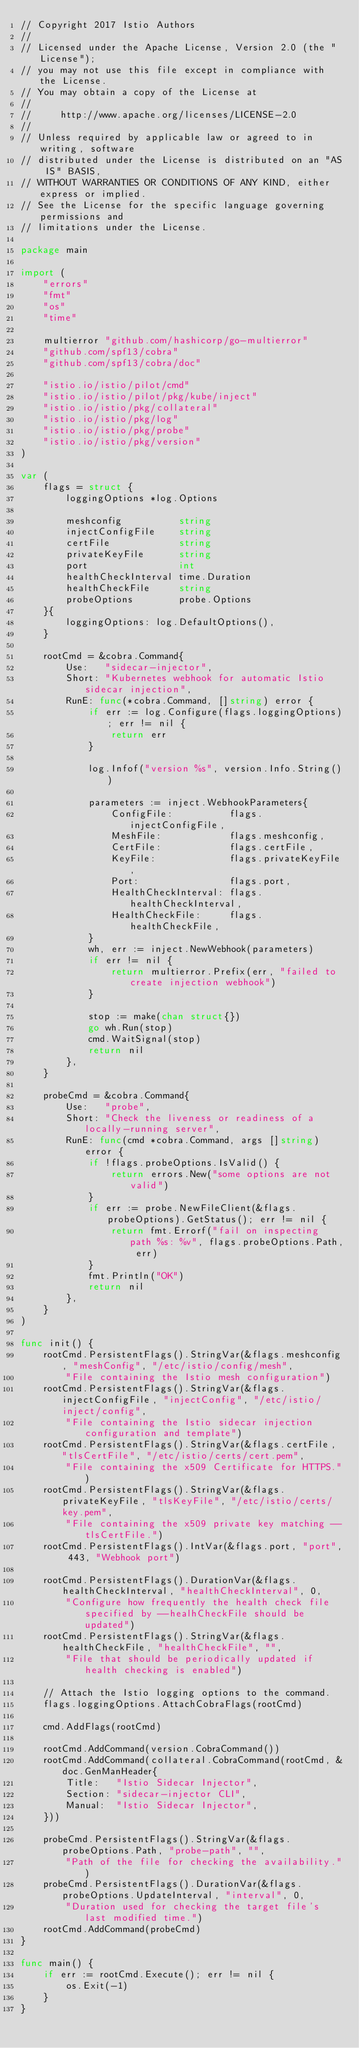<code> <loc_0><loc_0><loc_500><loc_500><_Go_>// Copyright 2017 Istio Authors
//
// Licensed under the Apache License, Version 2.0 (the "License");
// you may not use this file except in compliance with the License.
// You may obtain a copy of the License at
//
//     http://www.apache.org/licenses/LICENSE-2.0
//
// Unless required by applicable law or agreed to in writing, software
// distributed under the License is distributed on an "AS IS" BASIS,
// WITHOUT WARRANTIES OR CONDITIONS OF ANY KIND, either express or implied.
// See the License for the specific language governing permissions and
// limitations under the License.

package main

import (
	"errors"
	"fmt"
	"os"
	"time"

	multierror "github.com/hashicorp/go-multierror"
	"github.com/spf13/cobra"
	"github.com/spf13/cobra/doc"

	"istio.io/istio/pilot/cmd"
	"istio.io/istio/pilot/pkg/kube/inject"
	"istio.io/istio/pkg/collateral"
	"istio.io/istio/pkg/log"
	"istio.io/istio/pkg/probe"
	"istio.io/istio/pkg/version"
)

var (
	flags = struct {
		loggingOptions *log.Options

		meshconfig          string
		injectConfigFile    string
		certFile            string
		privateKeyFile      string
		port                int
		healthCheckInterval time.Duration
		healthCheckFile     string
		probeOptions        probe.Options
	}{
		loggingOptions: log.DefaultOptions(),
	}

	rootCmd = &cobra.Command{
		Use:   "sidecar-injector",
		Short: "Kubernetes webhook for automatic Istio sidecar injection",
		RunE: func(*cobra.Command, []string) error {
			if err := log.Configure(flags.loggingOptions); err != nil {
				return err
			}

			log.Infof("version %s", version.Info.String())

			parameters := inject.WebhookParameters{
				ConfigFile:          flags.injectConfigFile,
				MeshFile:            flags.meshconfig,
				CertFile:            flags.certFile,
				KeyFile:             flags.privateKeyFile,
				Port:                flags.port,
				HealthCheckInterval: flags.healthCheckInterval,
				HealthCheckFile:     flags.healthCheckFile,
			}
			wh, err := inject.NewWebhook(parameters)
			if err != nil {
				return multierror.Prefix(err, "failed to create injection webhook")
			}

			stop := make(chan struct{})
			go wh.Run(stop)
			cmd.WaitSignal(stop)
			return nil
		},
	}

	probeCmd = &cobra.Command{
		Use:   "probe",
		Short: "Check the liveness or readiness of a locally-running server",
		RunE: func(cmd *cobra.Command, args []string) error {
			if !flags.probeOptions.IsValid() {
				return errors.New("some options are not valid")
			}
			if err := probe.NewFileClient(&flags.probeOptions).GetStatus(); err != nil {
				return fmt.Errorf("fail on inspecting path %s: %v", flags.probeOptions.Path, err)
			}
			fmt.Println("OK")
			return nil
		},
	}
)

func init() {
	rootCmd.PersistentFlags().StringVar(&flags.meshconfig, "meshConfig", "/etc/istio/config/mesh",
		"File containing the Istio mesh configuration")
	rootCmd.PersistentFlags().StringVar(&flags.injectConfigFile, "injectConfig", "/etc/istio/inject/config",
		"File containing the Istio sidecar injection configuration and template")
	rootCmd.PersistentFlags().StringVar(&flags.certFile, "tlsCertFile", "/etc/istio/certs/cert.pem",
		"File containing the x509 Certificate for HTTPS.")
	rootCmd.PersistentFlags().StringVar(&flags.privateKeyFile, "tlsKeyFile", "/etc/istio/certs/key.pem",
		"File containing the x509 private key matching --tlsCertFile.")
	rootCmd.PersistentFlags().IntVar(&flags.port, "port", 443, "Webhook port")

	rootCmd.PersistentFlags().DurationVar(&flags.healthCheckInterval, "healthCheckInterval", 0,
		"Configure how frequently the health check file specified by --healhCheckFile should be updated")
	rootCmd.PersistentFlags().StringVar(&flags.healthCheckFile, "healthCheckFile", "",
		"File that should be periodically updated if health checking is enabled")

	// Attach the Istio logging options to the command.
	flags.loggingOptions.AttachCobraFlags(rootCmd)

	cmd.AddFlags(rootCmd)

	rootCmd.AddCommand(version.CobraCommand())
	rootCmd.AddCommand(collateral.CobraCommand(rootCmd, &doc.GenManHeader{
		Title:   "Istio Sidecar Injector",
		Section: "sidecar-injector CLI",
		Manual:  "Istio Sidecar Injector",
	}))

	probeCmd.PersistentFlags().StringVar(&flags.probeOptions.Path, "probe-path", "",
		"Path of the file for checking the availability.")
	probeCmd.PersistentFlags().DurationVar(&flags.probeOptions.UpdateInterval, "interval", 0,
		"Duration used for checking the target file's last modified time.")
	rootCmd.AddCommand(probeCmd)
}

func main() {
	if err := rootCmd.Execute(); err != nil {
		os.Exit(-1)
	}
}
</code> 